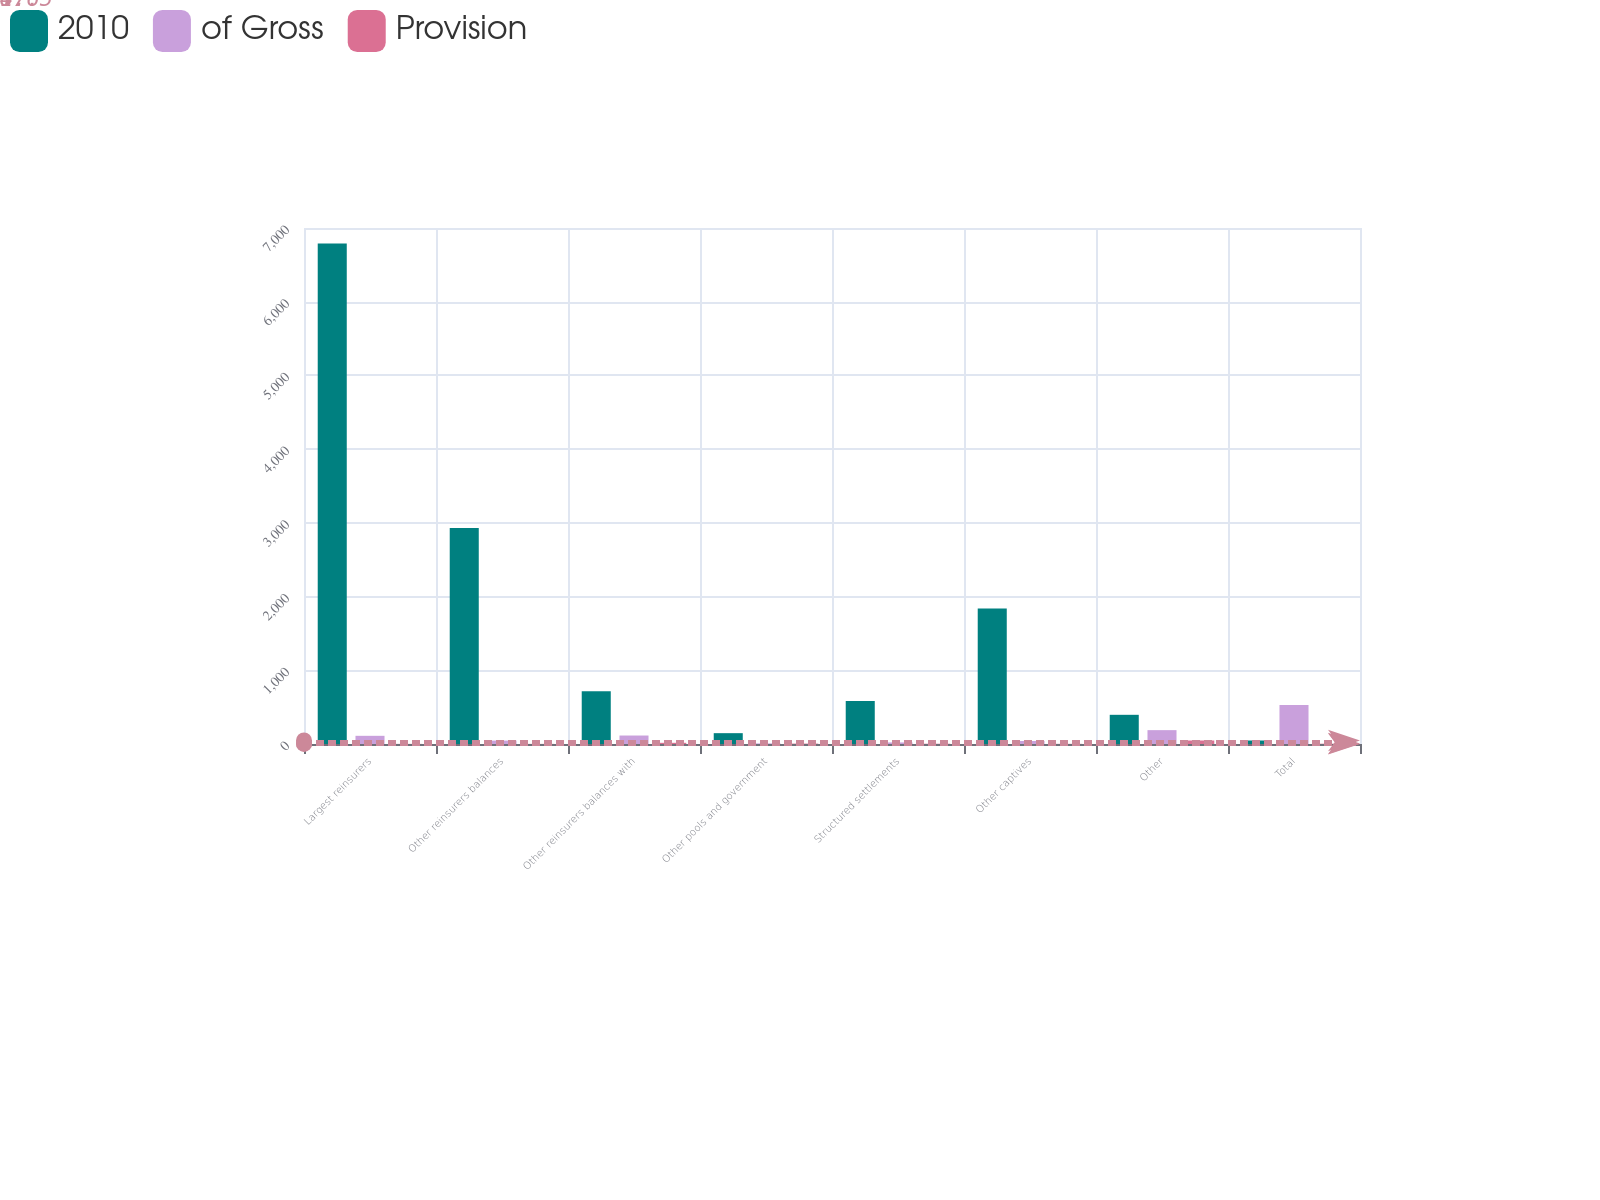<chart> <loc_0><loc_0><loc_500><loc_500><stacked_bar_chart><ecel><fcel>Largest reinsurers<fcel>Other reinsurers balances<fcel>Other reinsurers balances with<fcel>Other pools and government<fcel>Structured settlements<fcel>Other captives<fcel>Other<fcel>Total<nl><fcel>2010<fcel>6789<fcel>2931<fcel>715<fcel>147<fcel>585<fcel>1838<fcel>396<fcel>47.5<nl><fcel>of Gross<fcel>111<fcel>46<fcel>115<fcel>8<fcel>21<fcel>41<fcel>188<fcel>530<nl><fcel>Provision<fcel>1.6<fcel>1.6<fcel>16.1<fcel>5.4<fcel>3.6<fcel>2.2<fcel>47.5<fcel>4<nl></chart> 